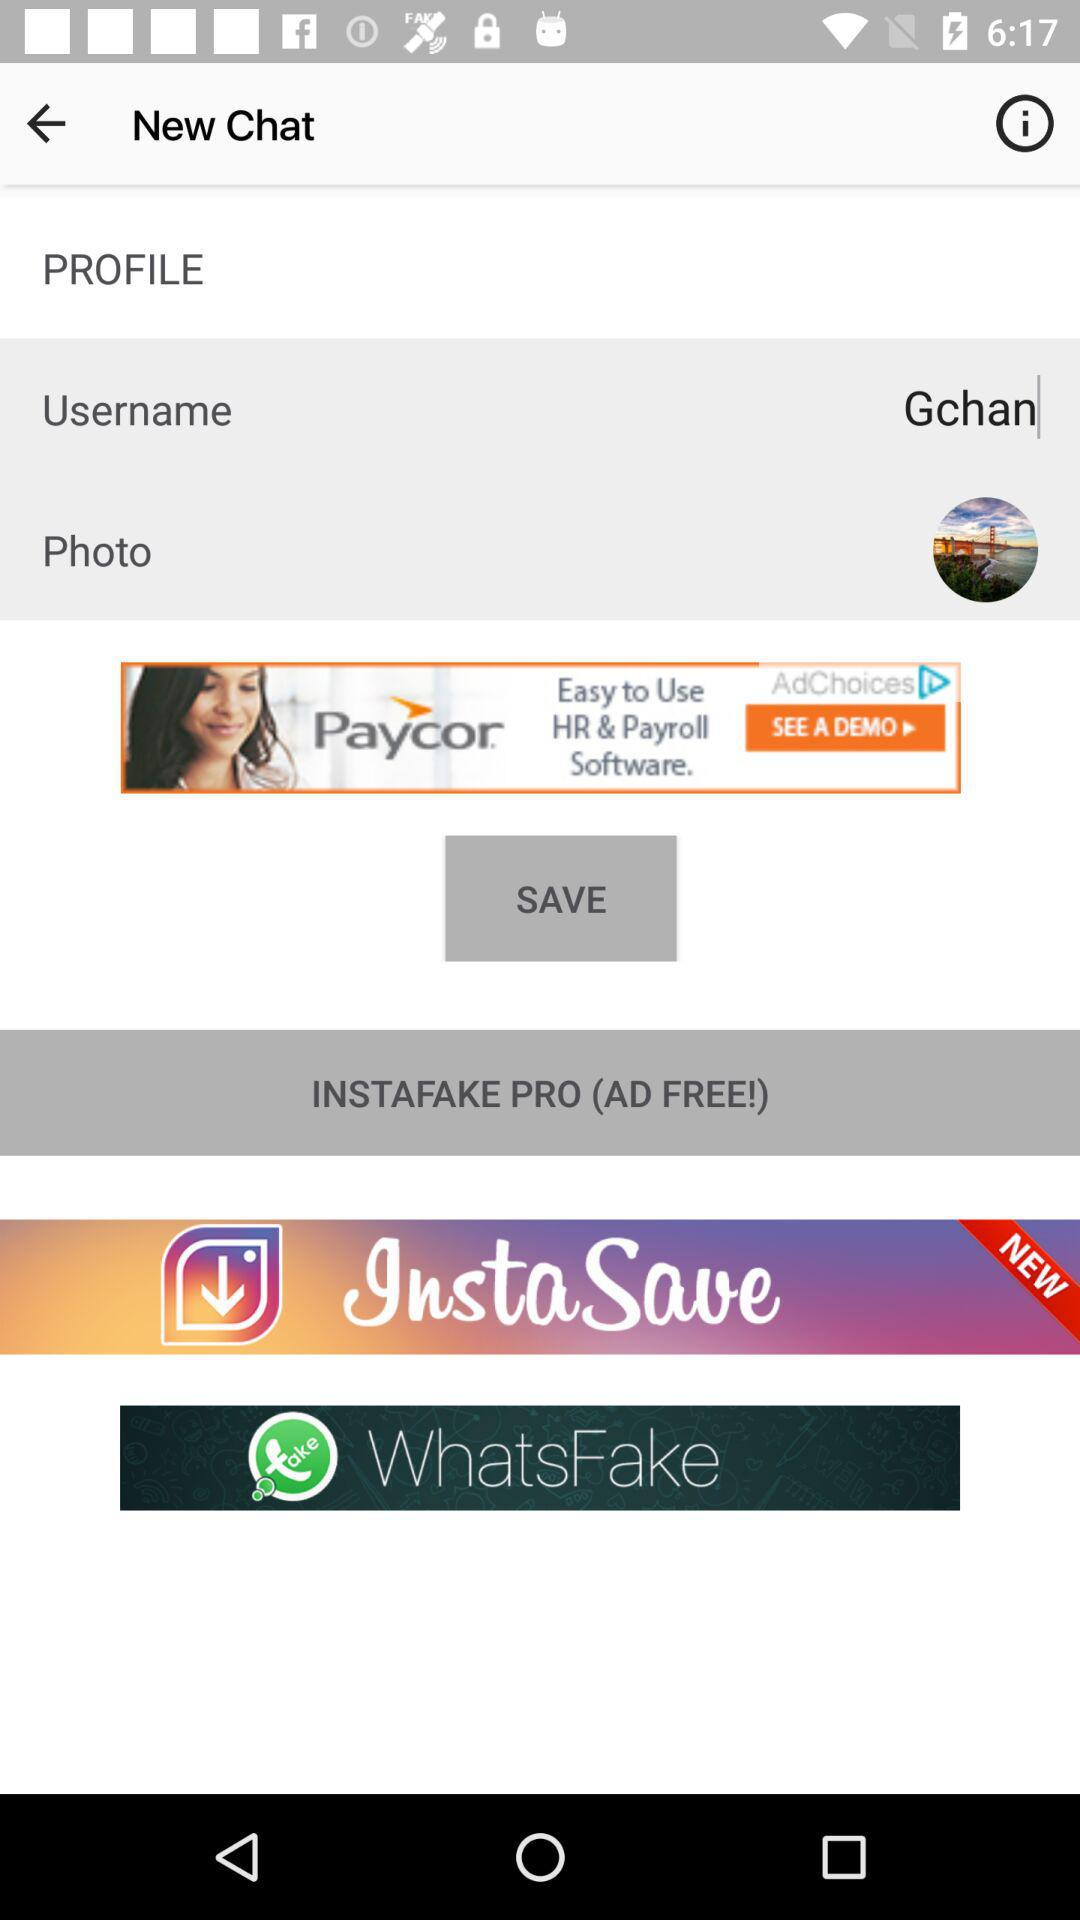What is the email of "Gchan"?
When the provided information is insufficient, respond with <no answer>. <no answer> 